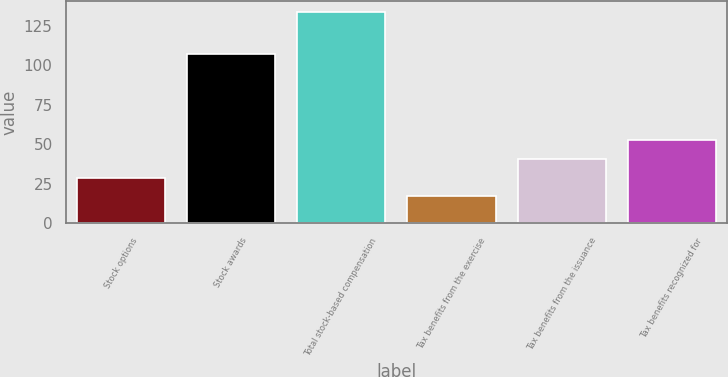<chart> <loc_0><loc_0><loc_500><loc_500><bar_chart><fcel>Stock options<fcel>Stock awards<fcel>Total stock-based compensation<fcel>Tax benefits from the exercise<fcel>Tax benefits from the issuance<fcel>Tax benefits recognized for<nl><fcel>28.7<fcel>107<fcel>134<fcel>17<fcel>40.4<fcel>53<nl></chart> 